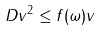<formula> <loc_0><loc_0><loc_500><loc_500>\| D v \| ^ { 2 } \leq \| f ( \omega ) \| \| v \|</formula> 